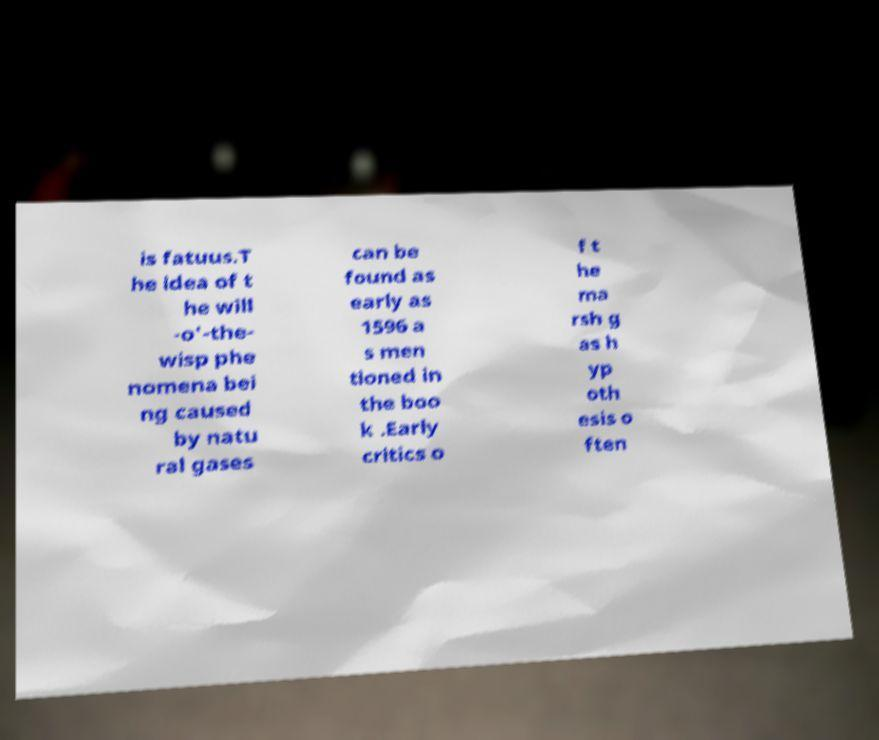I need the written content from this picture converted into text. Can you do that? is fatuus.T he idea of t he will -o'-the- wisp phe nomena bei ng caused by natu ral gases can be found as early as 1596 a s men tioned in the boo k .Early critics o f t he ma rsh g as h yp oth esis o ften 